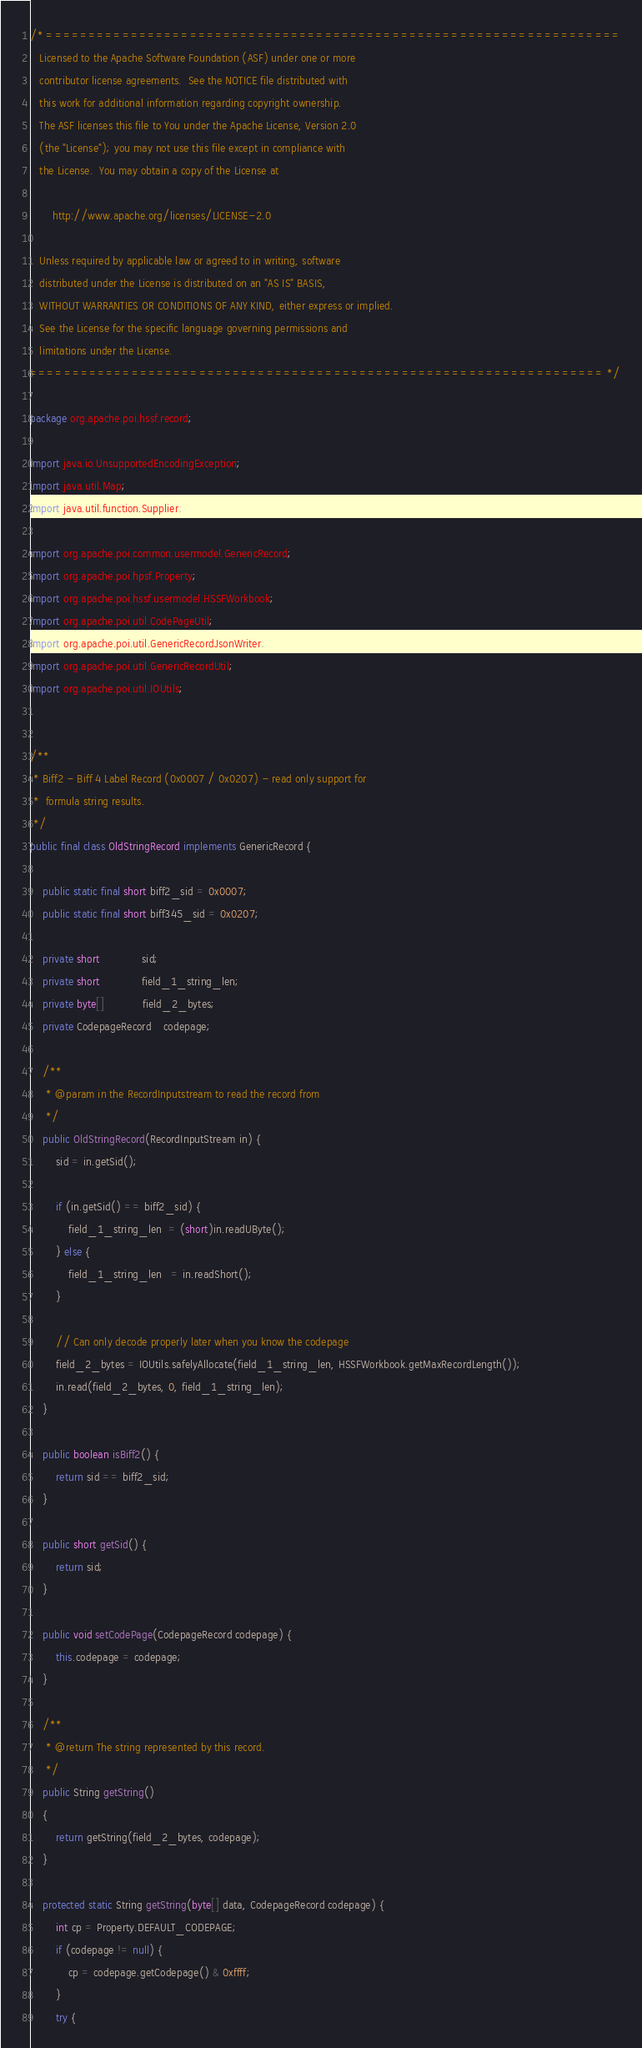<code> <loc_0><loc_0><loc_500><loc_500><_Java_>/* ====================================================================
   Licensed to the Apache Software Foundation (ASF) under one or more
   contributor license agreements.  See the NOTICE file distributed with
   this work for additional information regarding copyright ownership.
   The ASF licenses this file to You under the Apache License, Version 2.0
   (the "License"); you may not use this file except in compliance with
   the License.  You may obtain a copy of the License at

       http://www.apache.org/licenses/LICENSE-2.0

   Unless required by applicable law or agreed to in writing, software
   distributed under the License is distributed on an "AS IS" BASIS,
   WITHOUT WARRANTIES OR CONDITIONS OF ANY KIND, either express or implied.
   See the License for the specific language governing permissions and
   limitations under the License.
==================================================================== */

package org.apache.poi.hssf.record;

import java.io.UnsupportedEncodingException;
import java.util.Map;
import java.util.function.Supplier;

import org.apache.poi.common.usermodel.GenericRecord;
import org.apache.poi.hpsf.Property;
import org.apache.poi.hssf.usermodel.HSSFWorkbook;
import org.apache.poi.util.CodePageUtil;
import org.apache.poi.util.GenericRecordJsonWriter;
import org.apache.poi.util.GenericRecordUtil;
import org.apache.poi.util.IOUtils;


/**
 * Biff2 - Biff 4 Label Record (0x0007 / 0x0207) - read only support for
 *  formula string results.
 */
public final class OldStringRecord implements GenericRecord {

    public static final short biff2_sid = 0x0007;
    public static final short biff345_sid = 0x0207;

    private short             sid;
    private short             field_1_string_len;
    private byte[]            field_2_bytes;
    private CodepageRecord    codepage;

    /**
     * @param in the RecordInputstream to read the record from
     */
    public OldStringRecord(RecordInputStream in) {
        sid = in.getSid();

        if (in.getSid() == biff2_sid) {
            field_1_string_len  = (short)in.readUByte();
        } else {
            field_1_string_len   = in.readShort();
        }

        // Can only decode properly later when you know the codepage
        field_2_bytes = IOUtils.safelyAllocate(field_1_string_len, HSSFWorkbook.getMaxRecordLength());
        in.read(field_2_bytes, 0, field_1_string_len);
    }

    public boolean isBiff2() {
        return sid == biff2_sid;
    }

    public short getSid() {
        return sid;
    }

    public void setCodePage(CodepageRecord codepage) {
        this.codepage = codepage;
    }

    /**
     * @return The string represented by this record.
     */
    public String getString()
    {
        return getString(field_2_bytes, codepage);
    }

    protected static String getString(byte[] data, CodepageRecord codepage) {
        int cp = Property.DEFAULT_CODEPAGE;
        if (codepage != null) {
            cp = codepage.getCodepage() & 0xffff;
        }
        try {</code> 